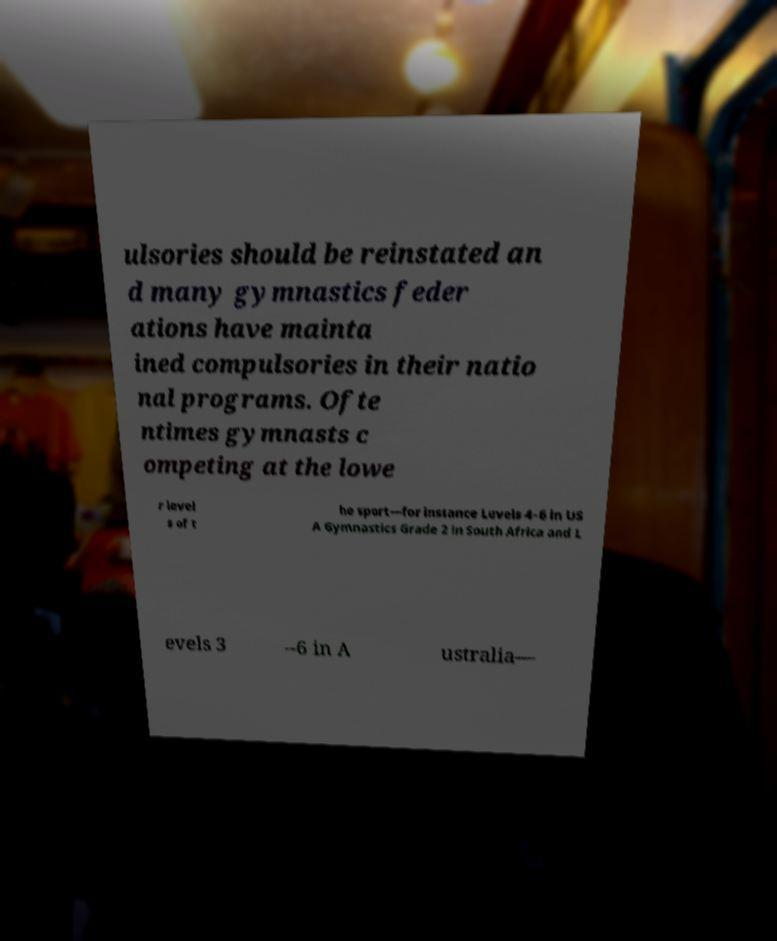Can you read and provide the text displayed in the image?This photo seems to have some interesting text. Can you extract and type it out for me? ulsories should be reinstated an d many gymnastics feder ations have mainta ined compulsories in their natio nal programs. Ofte ntimes gymnasts c ompeting at the lowe r level s of t he sport—for instance Levels 4–6 in US A Gymnastics Grade 2 in South Africa and L evels 3 –6 in A ustralia— 